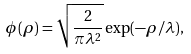Convert formula to latex. <formula><loc_0><loc_0><loc_500><loc_500>\phi ( \rho ) = \sqrt { \frac { 2 } { \pi \lambda ^ { 2 } } } \exp ( - \rho / \lambda ) ,</formula> 